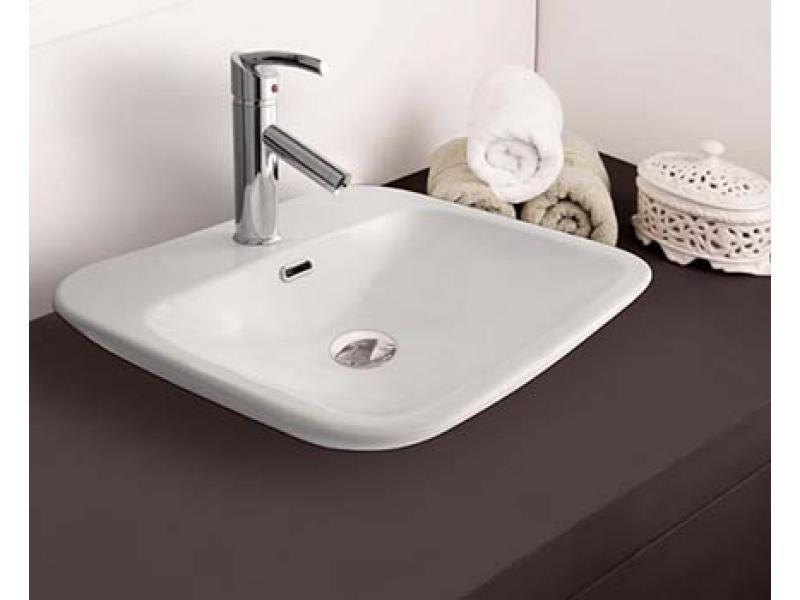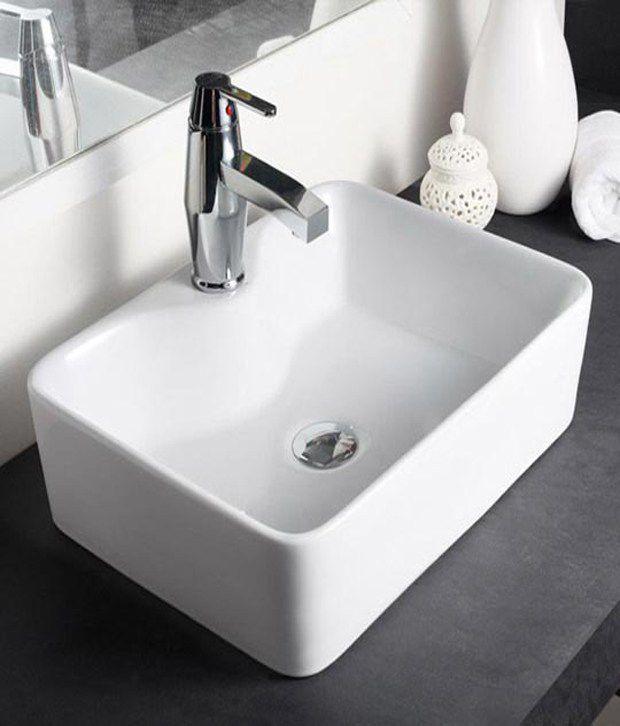The first image is the image on the left, the second image is the image on the right. For the images shown, is this caption "In one of the images there is a vase with yellow flowers placed on a counter next to a sink." true? Answer yes or no. No. 